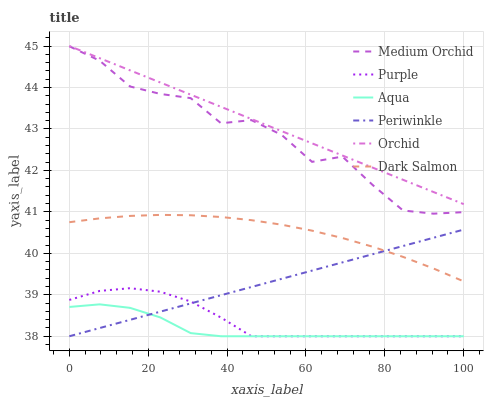Does Aqua have the minimum area under the curve?
Answer yes or no. Yes. Does Orchid have the maximum area under the curve?
Answer yes or no. Yes. Does Medium Orchid have the minimum area under the curve?
Answer yes or no. No. Does Medium Orchid have the maximum area under the curve?
Answer yes or no. No. Is Orchid the smoothest?
Answer yes or no. Yes. Is Medium Orchid the roughest?
Answer yes or no. Yes. Is Aqua the smoothest?
Answer yes or no. No. Is Aqua the roughest?
Answer yes or no. No. Does Medium Orchid have the lowest value?
Answer yes or no. No. Does Orchid have the highest value?
Answer yes or no. Yes. Does Medium Orchid have the highest value?
Answer yes or no. No. Is Purple less than Orchid?
Answer yes or no. Yes. Is Medium Orchid greater than Periwinkle?
Answer yes or no. Yes. Does Periwinkle intersect Aqua?
Answer yes or no. Yes. Is Periwinkle less than Aqua?
Answer yes or no. No. Is Periwinkle greater than Aqua?
Answer yes or no. No. Does Purple intersect Orchid?
Answer yes or no. No. 